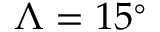<formula> <loc_0><loc_0><loc_500><loc_500>\Lambda = 1 5 ^ { \circ }</formula> 